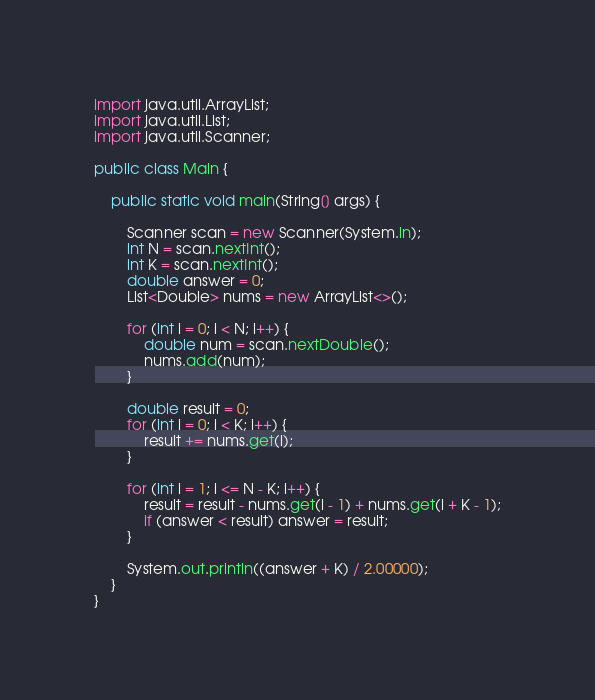<code> <loc_0><loc_0><loc_500><loc_500><_Java_>import java.util.ArrayList;
import java.util.List;
import java.util.Scanner;

public class Main {

	public static void main(String[] args) {

		Scanner scan = new Scanner(System.in);
		int N = scan.nextInt();
		int K = scan.nextInt();
		double answer = 0;
		List<Double> nums = new ArrayList<>();

		for (int i = 0; i < N; i++) {
			double num = scan.nextDouble();
			nums.add(num);
		}

		double result = 0;
		for (int i = 0; i < K; i++) {
			result += nums.get(i);
		}

		for (int i = 1; i <= N - K; i++) {
			result = result - nums.get(i - 1) + nums.get(i + K - 1);
			if (answer < result) answer = result;
		}

		System.out.println((answer + K) / 2.00000);
	}
}</code> 